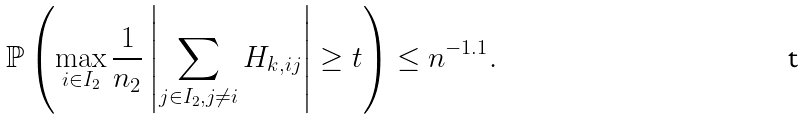Convert formula to latex. <formula><loc_0><loc_0><loc_500><loc_500>\mathbb { P } \left ( \max _ { i \in I _ { 2 } } \frac { 1 } { n _ { 2 } } \left | \sum _ { j \in I _ { 2 } , j \neq i } H _ { k , i j } \right | \geq t \right ) \leq n ^ { - 1 . 1 } .</formula> 